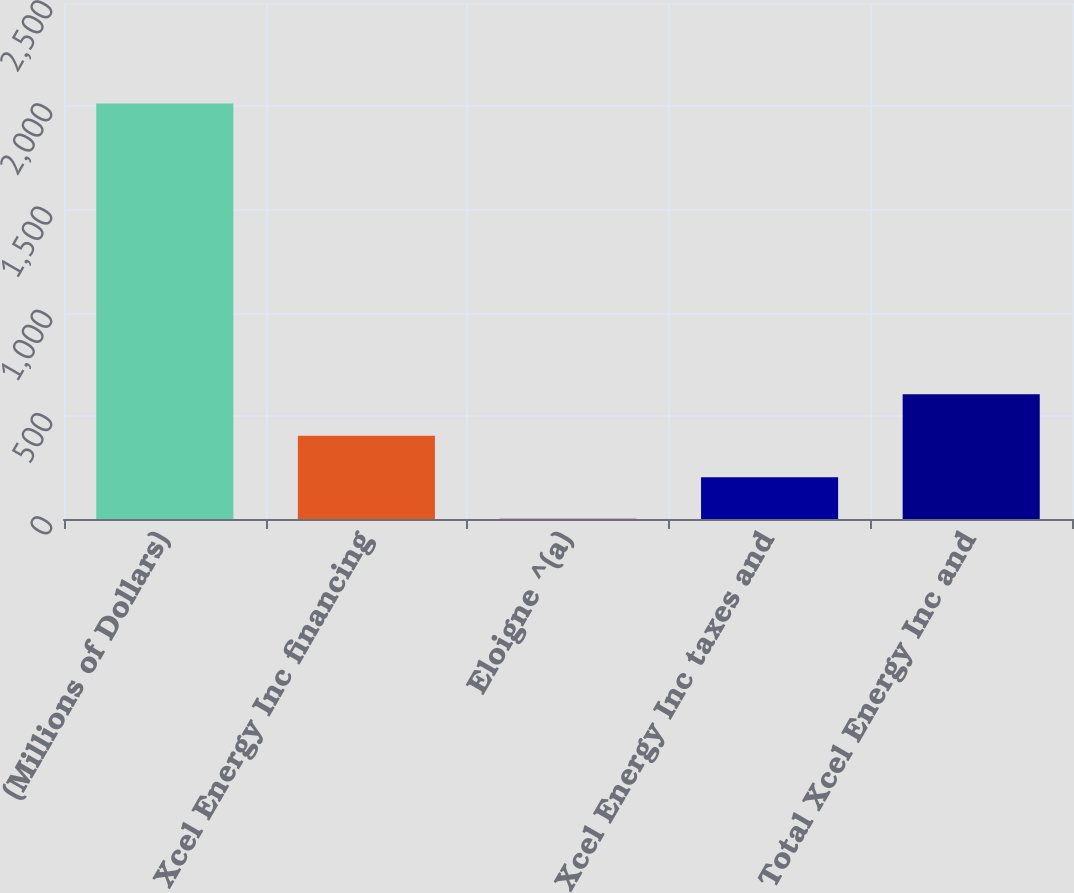Convert chart. <chart><loc_0><loc_0><loc_500><loc_500><bar_chart><fcel>(Millions of Dollars)<fcel>Xcel Energy Inc financing<fcel>Eloigne ^(a)<fcel>Xcel Energy Inc taxes and<fcel>Total Xcel Energy Inc and<nl><fcel>2013<fcel>403.24<fcel>0.8<fcel>202.02<fcel>604.46<nl></chart> 